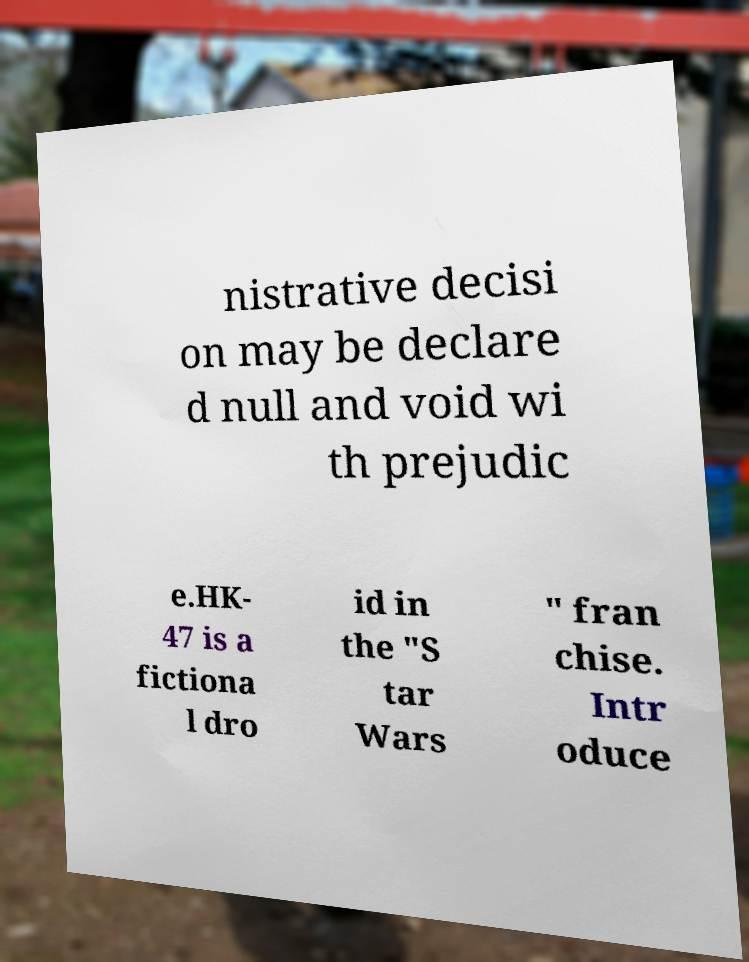Please read and relay the text visible in this image. What does it say? nistrative decisi on may be declare d null and void wi th prejudic e.HK- 47 is a fictiona l dro id in the "S tar Wars " fran chise. Intr oduce 